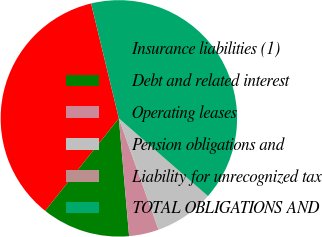Convert chart to OTSL. <chart><loc_0><loc_0><loc_500><loc_500><pie_chart><fcel>Insurance liabilities (1)<fcel>Debt and related interest<fcel>Operating leases<fcel>Pension obligations and<fcel>Liability for unrecognized tax<fcel>TOTAL OBLIGATIONS AND<nl><fcel>35.52%<fcel>12.09%<fcel>4.07%<fcel>8.08%<fcel>0.06%<fcel>40.18%<nl></chart> 